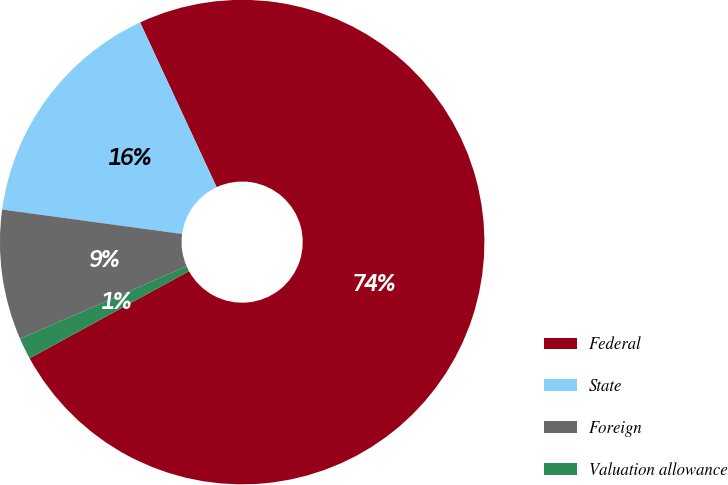Convert chart. <chart><loc_0><loc_0><loc_500><loc_500><pie_chart><fcel>Federal<fcel>State<fcel>Foreign<fcel>Valuation allowance<nl><fcel>73.96%<fcel>15.93%<fcel>8.68%<fcel>1.43%<nl></chart> 